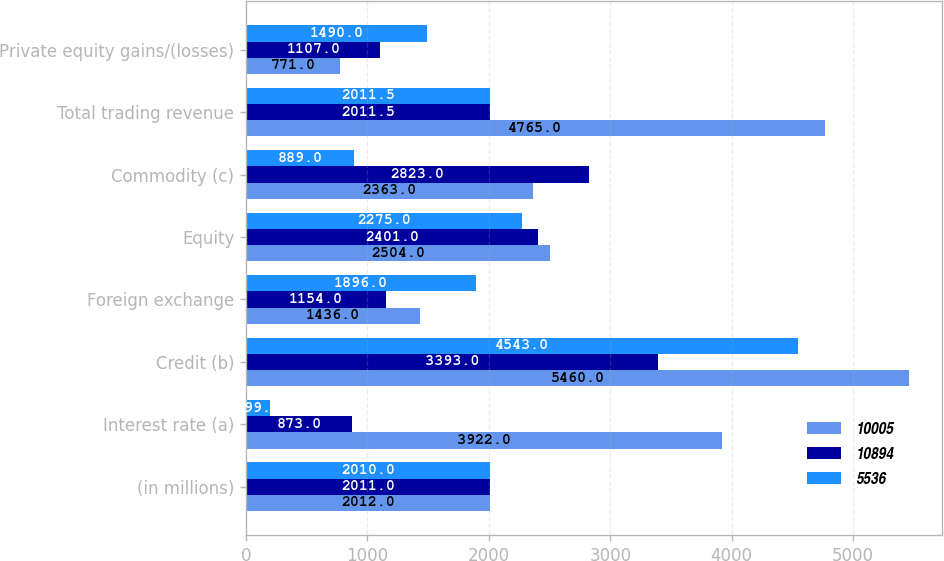Convert chart to OTSL. <chart><loc_0><loc_0><loc_500><loc_500><stacked_bar_chart><ecel><fcel>(in millions)<fcel>Interest rate (a)<fcel>Credit (b)<fcel>Foreign exchange<fcel>Equity<fcel>Commodity (c)<fcel>Total trading revenue<fcel>Private equity gains/(losses)<nl><fcel>10005<fcel>2012<fcel>3922<fcel>5460<fcel>1436<fcel>2504<fcel>2363<fcel>4765<fcel>771<nl><fcel>10894<fcel>2011<fcel>873<fcel>3393<fcel>1154<fcel>2401<fcel>2823<fcel>2011.5<fcel>1107<nl><fcel>5536<fcel>2010<fcel>199<fcel>4543<fcel>1896<fcel>2275<fcel>889<fcel>2011.5<fcel>1490<nl></chart> 